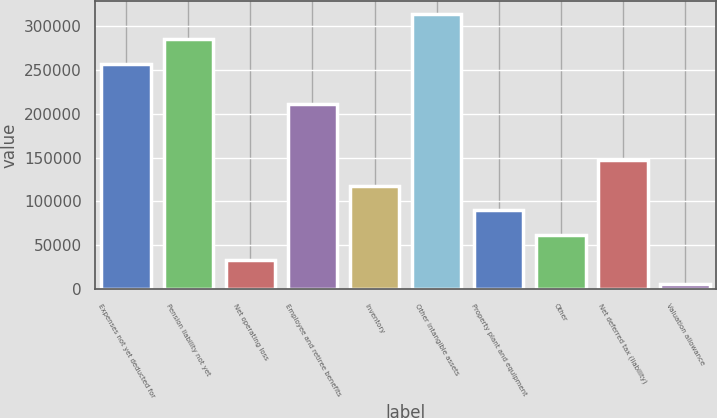<chart> <loc_0><loc_0><loc_500><loc_500><bar_chart><fcel>Expenses not yet deducted for<fcel>Pension liability not yet<fcel>Net operating loss<fcel>Employee and retiree benefits<fcel>Inventory<fcel>Other intangible assets<fcel>Property plant and equipment<fcel>Other<fcel>Net deferred tax (liability)<fcel>Valuation allowance<nl><fcel>256728<fcel>284871<fcel>33732.8<fcel>210429<fcel>118161<fcel>313014<fcel>90018.4<fcel>61875.6<fcel>147560<fcel>5590<nl></chart> 